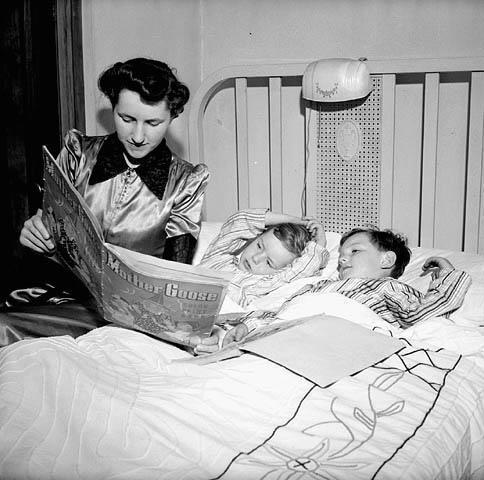Why is this book appropriate for her to read?
Make your selection and explain in format: 'Answer: answer
Rationale: rationale.'
Options: School book, nursery rhymes, romance novel, bible. Answer: nursery rhymes.
Rationale: There are toddlers in bed. 